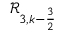Convert formula to latex. <formula><loc_0><loc_0><loc_500><loc_500>\mathcal { R } _ { 3 , k - \frac { 3 } { 2 } }</formula> 